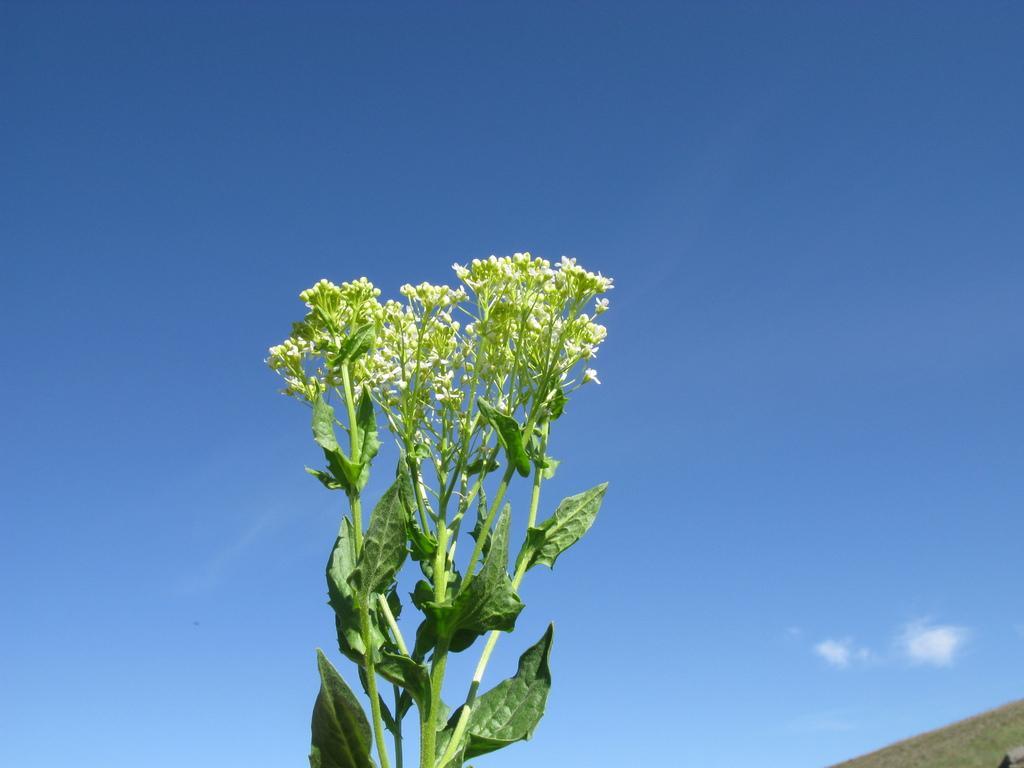Please provide a concise description of this image. In the center of the image we can see a plant with leaves and flowers. On the backside we can see the hill and the sky which looks cloudy. 